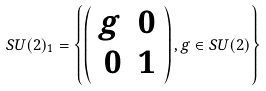<formula> <loc_0><loc_0><loc_500><loc_500>S U ( 2 ) _ { 1 } = \left \{ \left ( \begin{array} { r r } g & 0 \\ 0 & 1 \end{array} \right ) , g \in S U ( 2 ) \right \}</formula> 